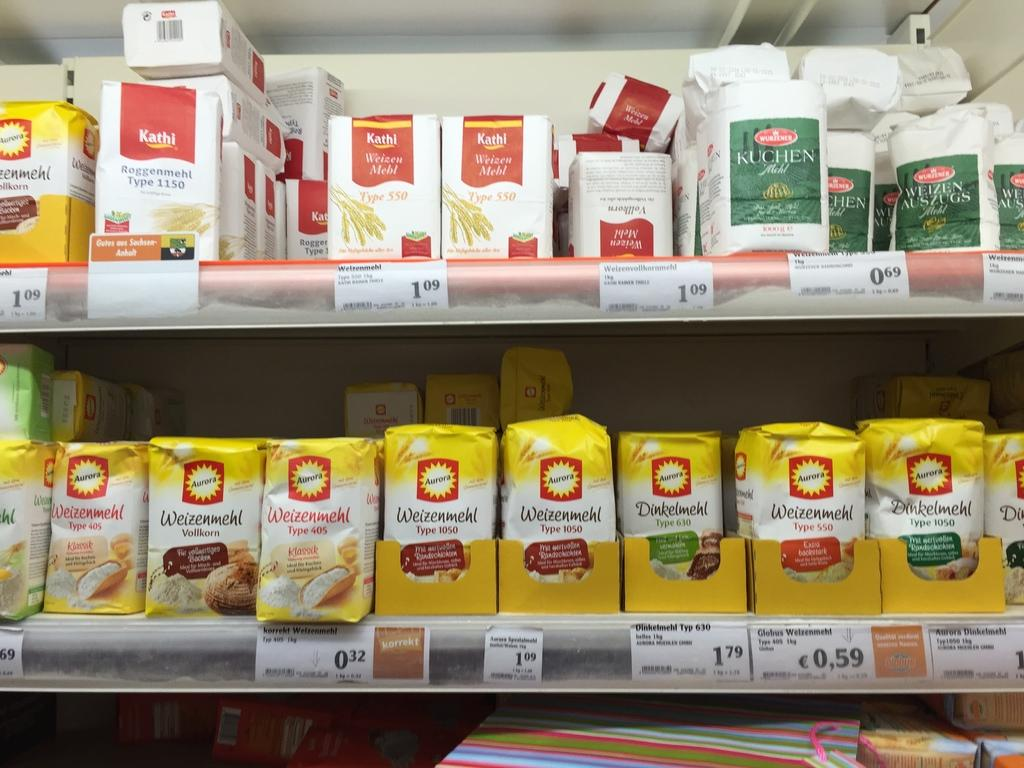<image>
Provide a brief description of the given image. the number 550 is on a yellow package 